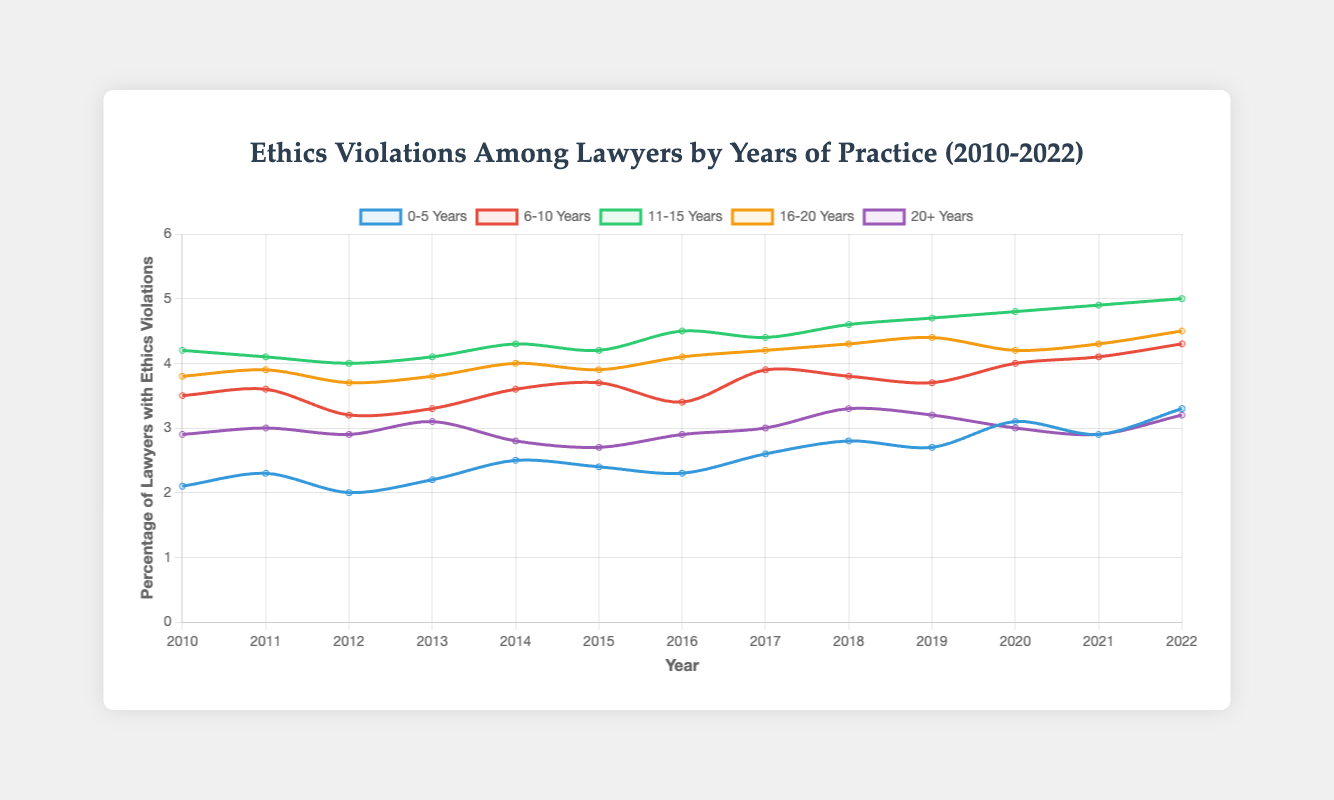What is the general trend in the percentage of lawyers with ethics violations in the 0-5 years of practice group from 2010 to 2022? From 2010 to 2022, the percentage generally increases from 2.1% in 2010 to 3.3% in 2022, with some fluctuations in between.
Answer: Increasing Which group had the highest percentage of lawyers with ethics violations in 2022? By looking at the last data point of each group in the figure, we see that the 11-15 years group had the highest percentage at 5.0%.
Answer: 11-15 Years In which year did the 16-20 years group experience the highest percentage of lawyers with ethics violations? The highest value for the 16-20 years group is 4.5%, which occurred in 2022.
Answer: 2022 How does the percentage of lawyers with ethics violations in the 6-10 years of practice group in 2015 compare to 2020? In 2015, the percentage is 3.7%, and in 2020, it's 4.0%. Comparing these, the percentage increased by 0.3% from 2015 to 2020.
Answer: Increased Which group showed the least fluctuation in the percentage of lawyers with ethics violations over the entire period? By visual inspection, the 0-5 years group showed the least fluctuation, staying within a narrower range compared to other groups.
Answer: 0-5 Years What is the average percentage of lawyers with ethics violations for the 20+ years group from 2010 to 2022? Sum of percentages: 2.9 + 3.0 + 2.9 + 3.1 + 2.8 + 2.7 + 2.9 + 3.0 + 3.3 + 3.2 + 3.0 + 2.9 + 3.2 = 39.9. Average = 39.9 / 13 ≈ 3.07%.
Answer: 3.07% Between which years did the 11-15 years group have the greatest increase in the percentage of ethics violations? By examining the changes each year, the greatest increase appears between 2021 (4.9%) and 2022 (5.0%), which is an increase of 0.1%.
Answer: 2021-2022 Which group had a decrease in the percentage of lawyers with ethics violations from 2019 to 2020? From 2019 (3.2%) to 2020 (3.0%), the 20+ years group saw a decrease of 0.2%.
Answer: 20+ Years 